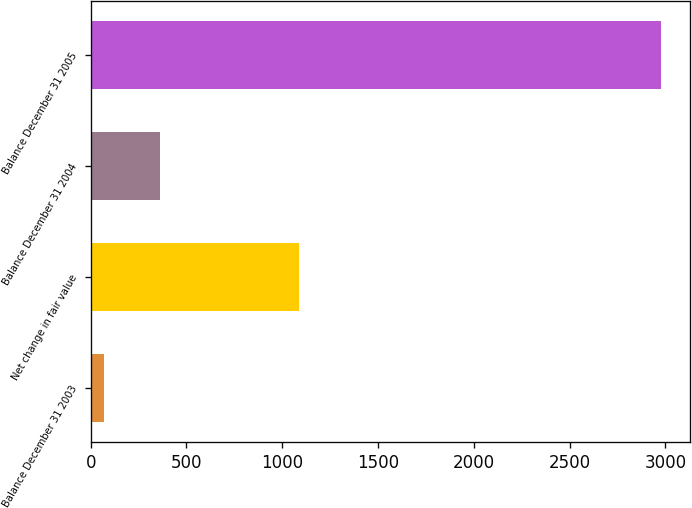Convert chart. <chart><loc_0><loc_0><loc_500><loc_500><bar_chart><fcel>Balance December 31 2003<fcel>Net change in fair value<fcel>Balance December 31 2004<fcel>Balance December 31 2005<nl><fcel>70<fcel>1088<fcel>360.8<fcel>2978<nl></chart> 